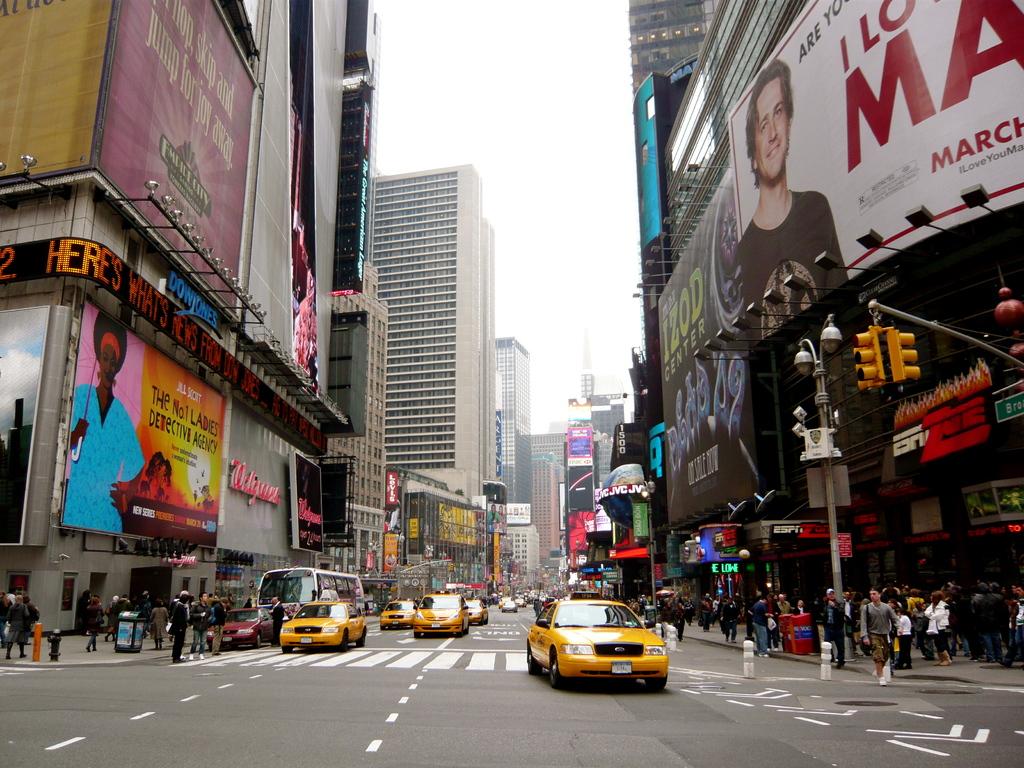What pharmacy is above the bus?
Ensure brevity in your answer.  Walgreens. 